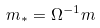<formula> <loc_0><loc_0><loc_500><loc_500>m _ { * } = \Omega ^ { - 1 } m</formula> 